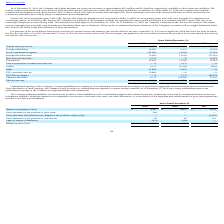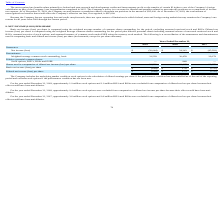According to Immersion's financial document, How does the company account for interest and penalties related to uncertain tax positions? as a component of income tax expense.. The document states: "t and penalties related to uncertain tax positions as a component of income tax expense. As of December 31, 2019, the Company accrued interest or pena..." Also, What was the total amount of unrecognized tax benefits that would affect the Company’s effective tax rate as of December 31, 2019? According to the financial document, $97,000. The relevant text states: "he Company’s effective tax rate, if recognized, is $97,000...." Also, What was the Gross increases for tax positions of prior years in 2019, 2018 and 2017? The document contains multiple relevant values: 394, 0, 0 (in thousands). From the document: "Gross increases for tax positions of prior years 394 — — 2019 2018 2017..." Additionally, In which year was the Balance at beginning of year less than 5,000 thousands? The document shows two values: 2019 and 2018. Locate and analyze balance at beginning of year in row 3. From the document: "2019 2018 2017 2019 2018 2017..." Also, can you calculate: What was the change in the Gross increases for tax positions of prior years from 2018 to 2019? Based on the calculation: 394 - 0, the result is 394 (in thousands). This is based on the information: "Gross increases for tax positions of prior years 394 — — 2019 2018 2017..." The key data points involved are: 0. Also, can you calculate: What was the average Gross increases for tax positions of current year for 2017-2019? To answer this question, I need to perform calculations using the financial data. The calculation is: (34 + 45 + 110) / 3, which equals 63 (in thousands). This is based on the information: "ss increases for tax positions of current year 34 45 110 Gross increases for tax positions of current year 34 45 110 increases for tax positions of current year 34 45 110..." The key data points involved are: 110, 34, 45. 